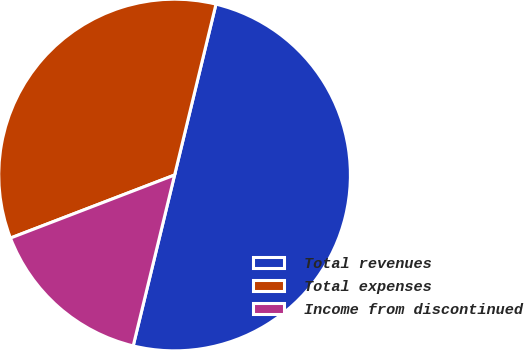<chart> <loc_0><loc_0><loc_500><loc_500><pie_chart><fcel>Total revenues<fcel>Total expenses<fcel>Income from discontinued<nl><fcel>50.0%<fcel>34.62%<fcel>15.38%<nl></chart> 